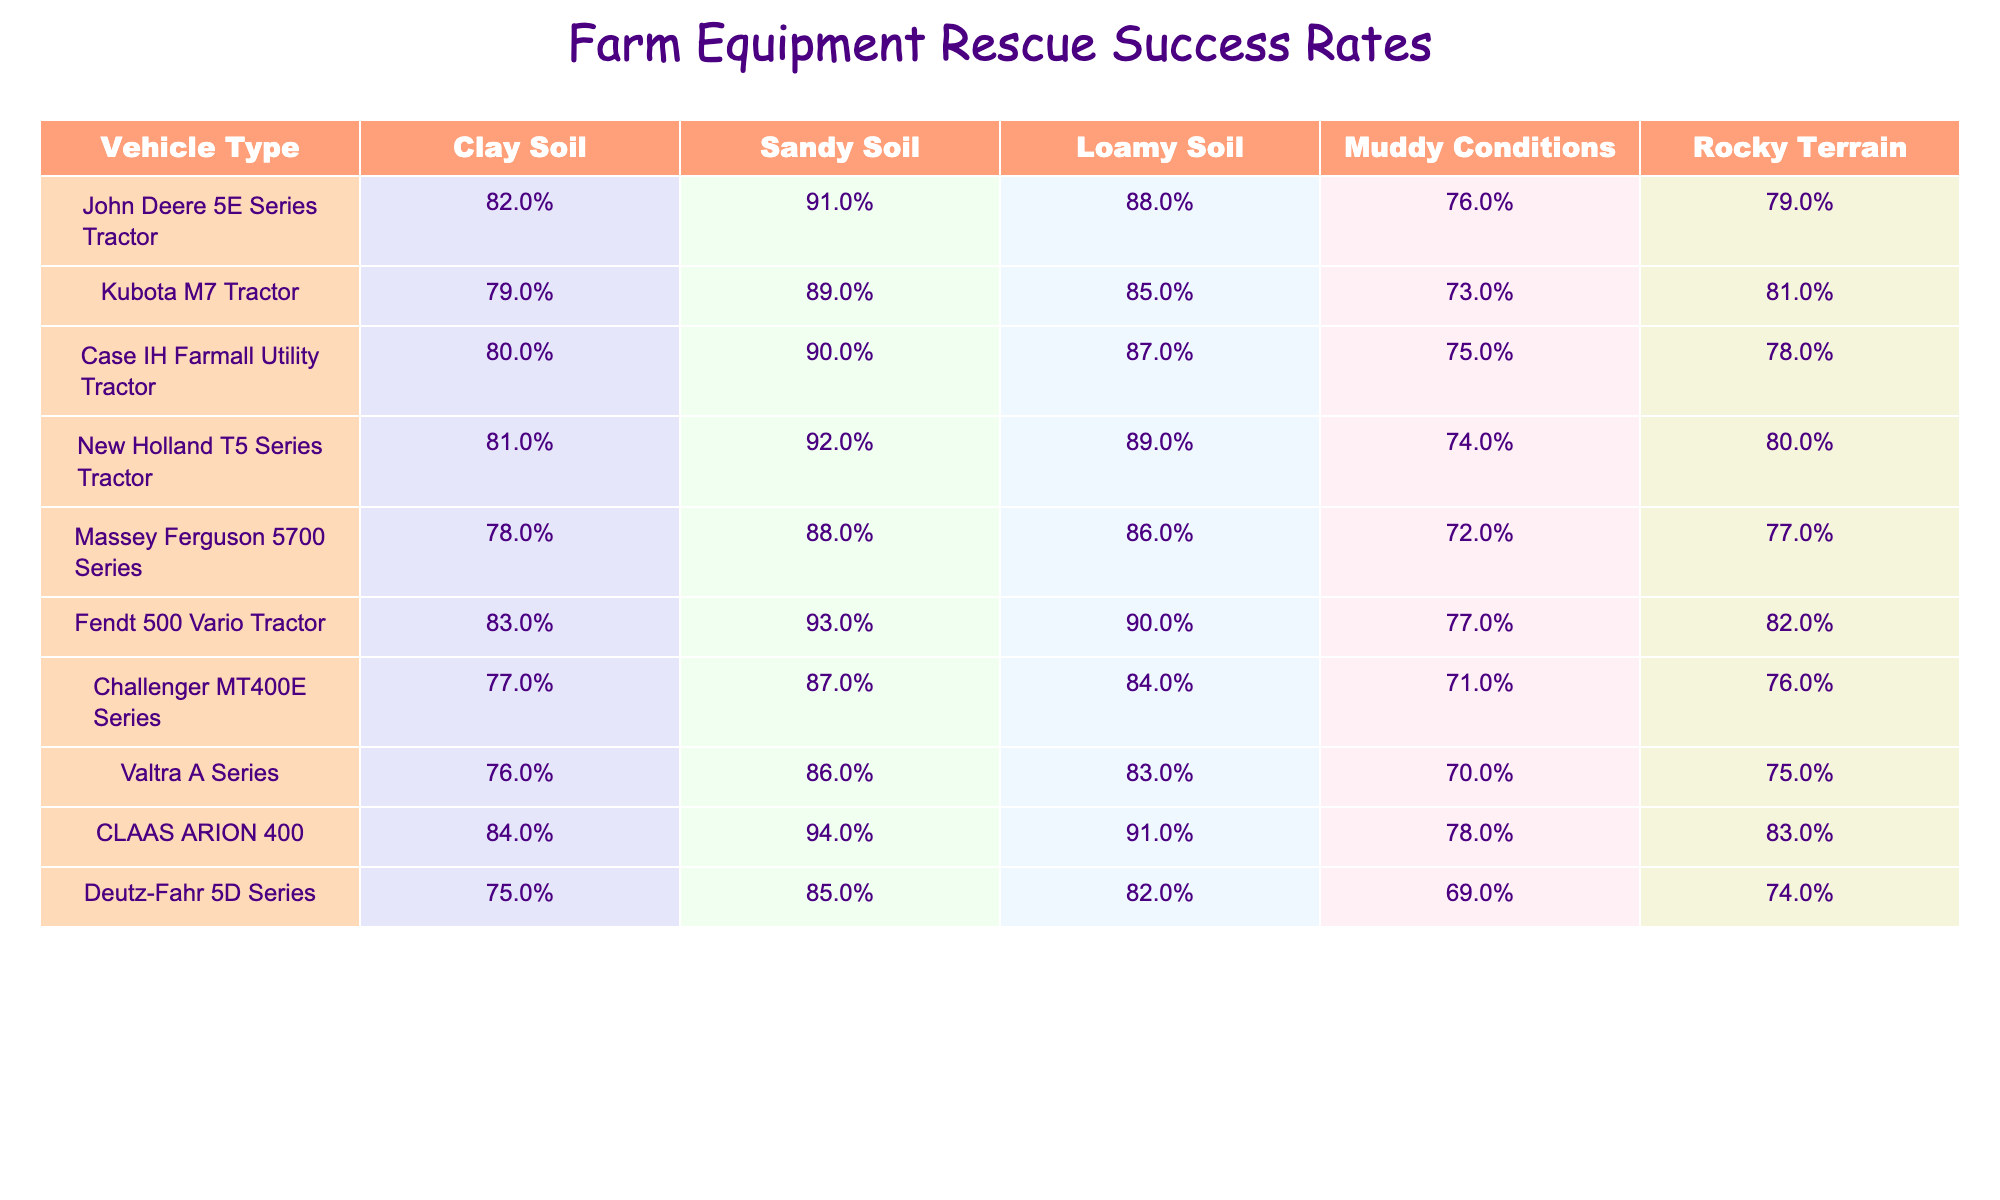What's the success rate of the New Holland T5 Series Tractor in sandy soil? The table shows that the New Holland T5 Series Tractor has a success rate of 92% in sandy soil.
Answer: 92% Which vehicle has the highest success rate in muddy conditions? By looking at the muddy conditions column, the CLAAS ARION 400 has the highest success rate at 78%.
Answer: CLAAS ARION 400 What is the average success rate across all vehicle types for loamy soil? To find the average for loamy soil, add all the loamy soil success rates (88% + 85% + 87% + 89% + 86% + 90% + 84% + 83% + 91% + 82% = 872%) and divide by the number of vehicles (10). Thus, 872% / 10 = 87.2%.
Answer: 87.2% Is the success rate of the Fendt 500 Vario Tractor higher in clay soil or rocky terrain? In clay soil, the Fendt 500 Vario Tractor has a success rate of 83%, while in rocky terrain it has 82%. Therefore, its rate is higher in clay soil.
Answer: Yes What is the difference in success rates for the Case IH Farmall Utility Tractor between clay soil and muddy conditions? The Case IH Farmall Utility Tractor has a success rate of 80% in clay soil and 75% in muddy conditions. The difference is 80% - 75% = 5%.
Answer: 5% Which vehicle type is least successful in muddy conditions? The table reveals that the Challenger MT400E Series has the lowest success rate of 71% in muddy conditions compared to other vehicles listed.
Answer: Challenger MT400E Series Which vehicle type exhibits the greatest overall performance across all soil conditions? To assess overall performance, we can sum the success rates for each vehicle over all soil conditions and compare them. After calculating, the Fendt 500 Vario Tractor has the highest total of approximately 415% (totaling its rates), making it the best performer.
Answer: Fendt 500 Vario Tractor Do tractors generally perform better in sandy soil compared to muddy conditions? By comparing the success rates, we can examine the average of sandy versus muddy: average sandy (88%) and average muddy (75.9%) show that success rates are generally higher in sandy soil.
Answer: Yes 